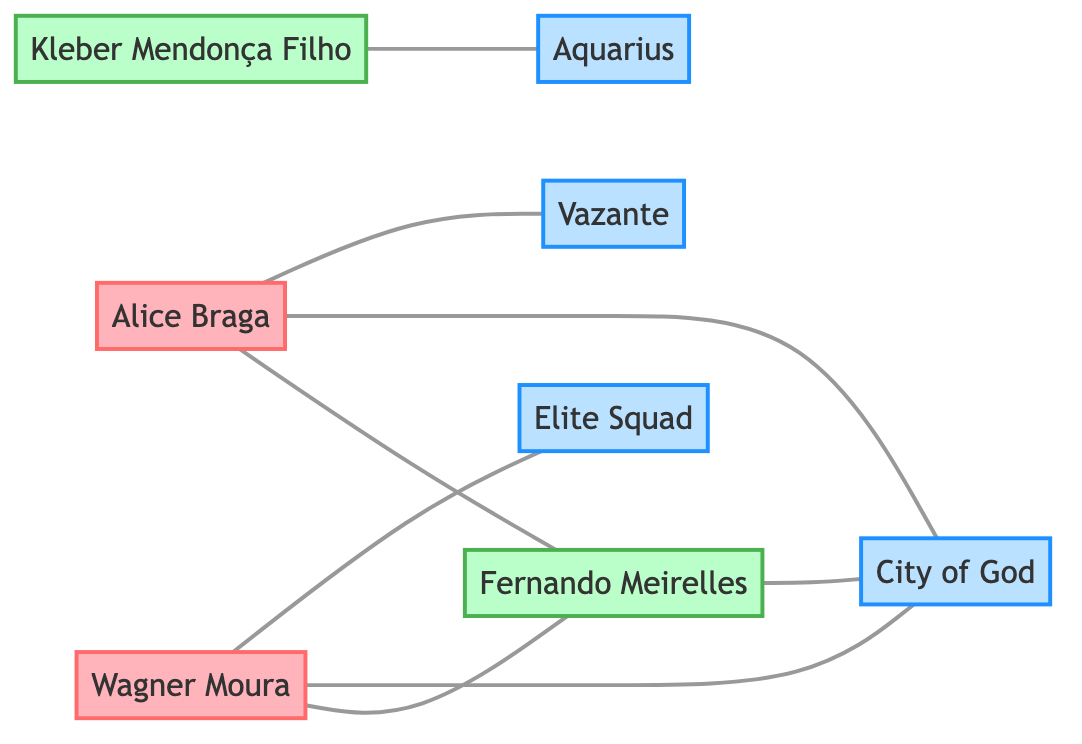What is the total number of actors in the diagram? By counting the distinct nodes labeled as actors, we identify Wagner Moura and Alice Braga as the only actor nodes, leading to a total of 2 actors.
Answer: 2 Which director collaborated with Wagner Moura? The edge labeled "collaborated_in" between Wagner Moura and Fernando Meirelles indicates that he collaborated with Fernando Meirelles.
Answer: Fernando Meirelles How many movies did Alice Braga act in according to the diagram? The diagram shows two edges indicating Alice Braga acted in two movies: City of God and Vazante, giving a total of 2 movies.
Answer: 2 Which movie was directed by Fernando Meirelles? The directed edge from Fernando Meirelles to the node City of God signifies that he directed this movie.
Answer: City of God Who directed the movie Aquarius? The directed edge connects Kleber Mendonça Filho to the movie Aquarius, so he is the director of Aquarius.
Answer: Kleber Mendonça Filho What is the relationship between Alice Braga and City of God? The edges indicate that Alice Braga acted in City of God and also collaborated with Fernando Meirelles on this film, showing she has a significant role related to this movie.
Answer: acted_in Which movie features both actors Wagner Moura and Alice Braga? Both actors are connected to the same movie node City of God, indicating it features both of them.
Answer: City of God How many directors are present in the diagram? The nodes labeled as directors are Fernando Meirelles and Kleber Mendonça Filho. By counting these distinct nodes, we find there are 2 directors present.
Answer: 2 